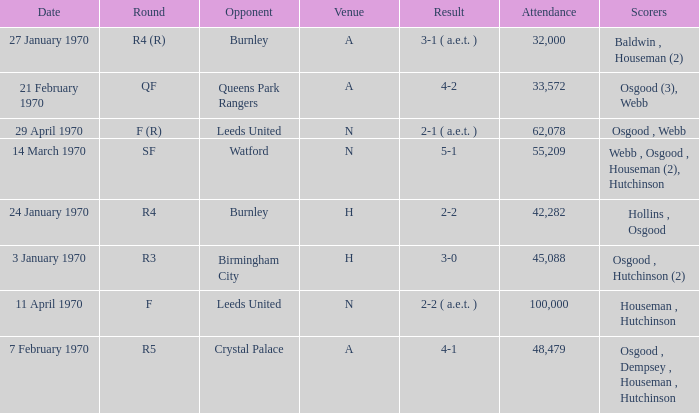What is the highest attendance at a game with a result of 5-1? 55209.0. 